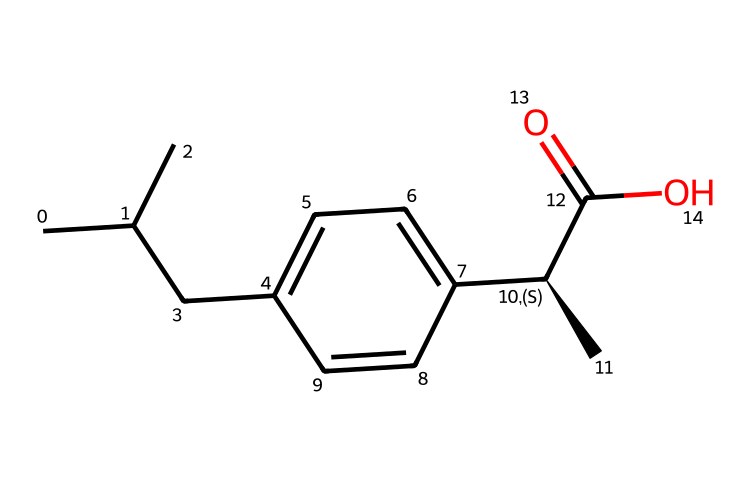what is the molecular formula of ibuprofen? To determine the molecular formula, we count the number of each type of atom present in the structure. From the SMILES representation, we see there are 13 carbon (C) atoms, 18 hydrogen (H) atoms, and 2 oxygen (O) atoms. This gives us the formula C13H18O2.
Answer: C13H18O2 how many chiral centers are present in ibuprofen? By analyzing the structure, we identify the chiral center, which is denoted by the "C@H" in the SMILES. There is one carbon atom attached to four different substituents, indicating a single chiral center.
Answer: 1 what type of compound is ibuprofen? Considering that ibuprofen has a specific functional group (carboxylic acid) and contains an asymmetric carbon center, it is classified as a non-steroidal anti-inflammatory drug (NSAID).
Answer: NSAID what functional groups are present in ibuprofen? The structure includes a carboxylic acid group (–COOH) and an aromatic ring, which are essential in defining its properties. This can be identified by looking for the –COOH in the SMILES representation and the cyclic carbon atoms in the aromatic section.
Answer: carboxylic acid and aromatic why is ibuprofen considered a chiral compound? Ibuprofen is considered chiral because it contains a carbon atom that is bonded to four distinct groups, resulting in non-superimposable mirror images (enantiomers). This is evident from the "C@H" marking in the SMILES representation.
Answer: non-superimposable mirror images what are the implications of ibuprofen’s chirality in pharmacology? The chirality of ibuprofen is crucial as the different enantiomers can have varying efficacy and safety profiles. Typically, one enantiomer is responsible for the desired therapeutic effects, while the other may cause side effects or be inactive.
Answer: varying efficacy and safety profiles 